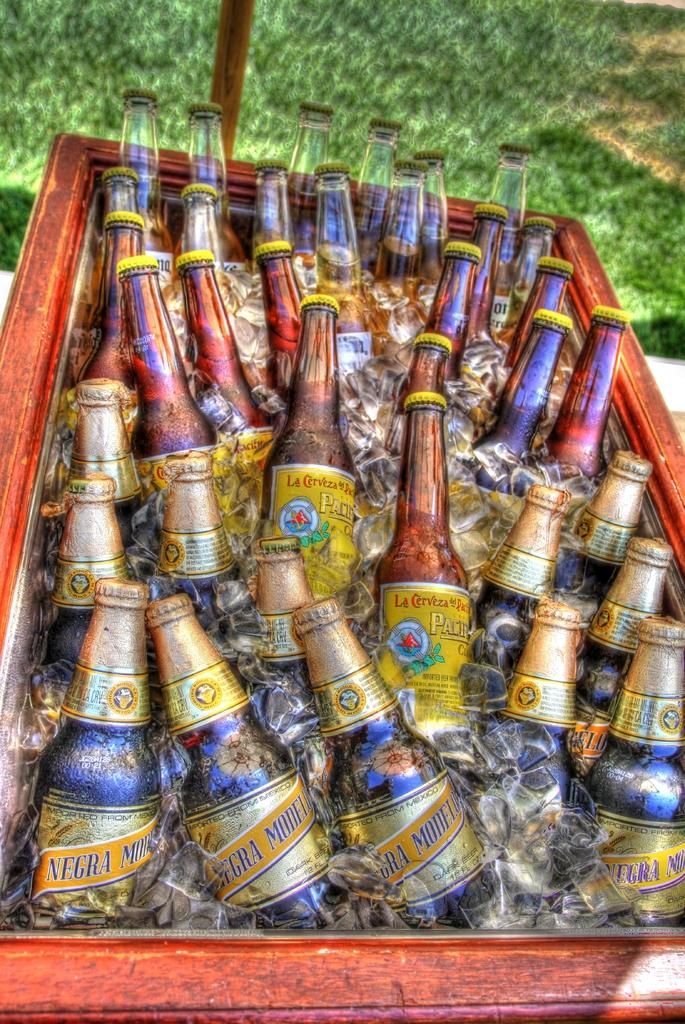Provide a one-sentence caption for the provided image. Negra Modelo is one of the beer choices in the container. 